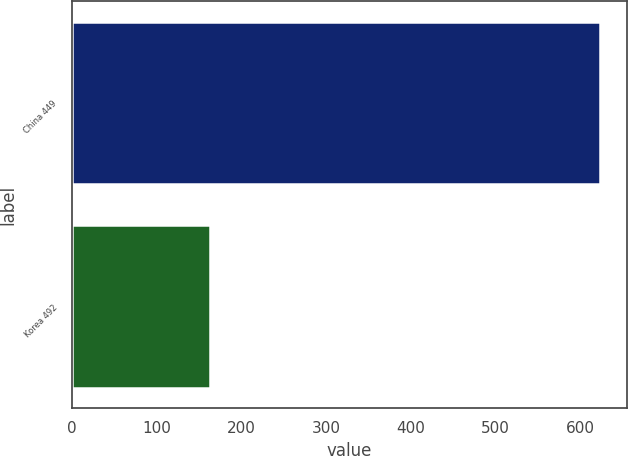Convert chart to OTSL. <chart><loc_0><loc_0><loc_500><loc_500><bar_chart><fcel>China 449<fcel>Korea 492<nl><fcel>624<fcel>163<nl></chart> 